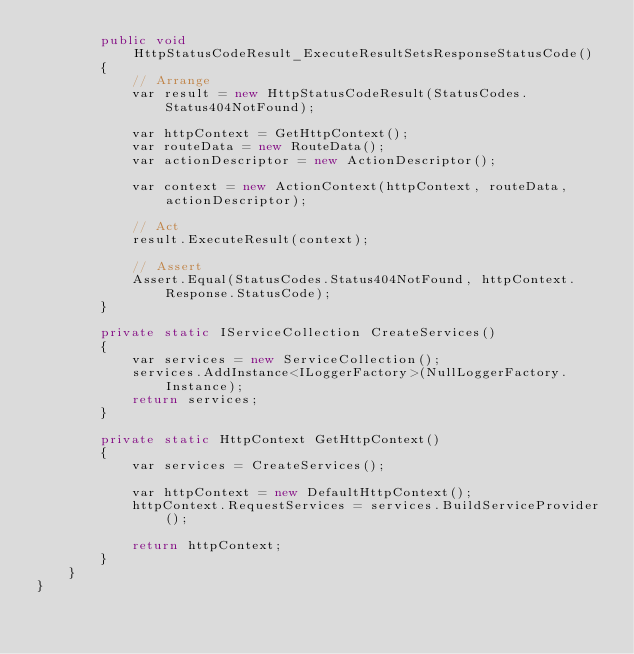Convert code to text. <code><loc_0><loc_0><loc_500><loc_500><_C#_>        public void HttpStatusCodeResult_ExecuteResultSetsResponseStatusCode()
        {
            // Arrange
            var result = new HttpStatusCodeResult(StatusCodes.Status404NotFound);

            var httpContext = GetHttpContext();
            var routeData = new RouteData();
            var actionDescriptor = new ActionDescriptor();

            var context = new ActionContext(httpContext, routeData, actionDescriptor);

            // Act
            result.ExecuteResult(context);

            // Assert
            Assert.Equal(StatusCodes.Status404NotFound, httpContext.Response.StatusCode);
        }

        private static IServiceCollection CreateServices()
        {
            var services = new ServiceCollection();
            services.AddInstance<ILoggerFactory>(NullLoggerFactory.Instance);
            return services;
        }

        private static HttpContext GetHttpContext()
        {
            var services = CreateServices();

            var httpContext = new DefaultHttpContext();
            httpContext.RequestServices = services.BuildServiceProvider();

            return httpContext;
        }
    }
}</code> 